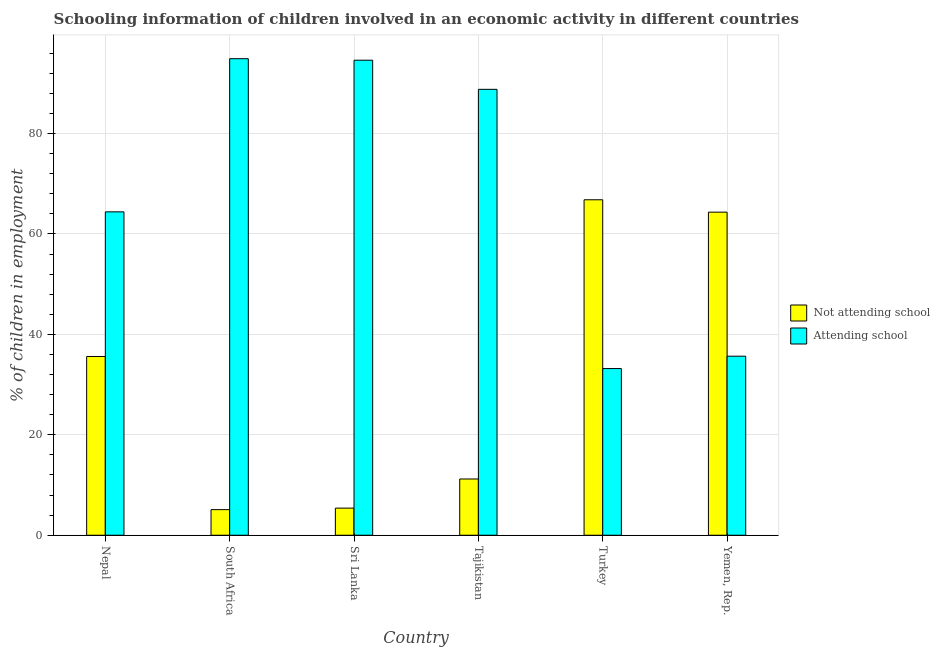How many different coloured bars are there?
Your response must be concise. 2. How many groups of bars are there?
Your answer should be very brief. 6. Are the number of bars per tick equal to the number of legend labels?
Offer a very short reply. Yes. How many bars are there on the 5th tick from the left?
Offer a terse response. 2. What is the label of the 3rd group of bars from the left?
Offer a terse response. Sri Lanka. In how many cases, is the number of bars for a given country not equal to the number of legend labels?
Make the answer very short. 0. What is the percentage of employed children who are not attending school in Sri Lanka?
Make the answer very short. 5.4. Across all countries, what is the maximum percentage of employed children who are not attending school?
Ensure brevity in your answer.  66.81. In which country was the percentage of employed children who are not attending school maximum?
Ensure brevity in your answer.  Turkey. In which country was the percentage of employed children who are not attending school minimum?
Offer a terse response. South Africa. What is the total percentage of employed children who are not attending school in the graph?
Your response must be concise. 188.45. What is the difference between the percentage of employed children who are not attending school in South Africa and that in Yemen, Rep.?
Offer a very short reply. -59.24. What is the difference between the percentage of employed children who are not attending school in Nepal and the percentage of employed children who are attending school in South Africa?
Provide a succinct answer. -59.3. What is the average percentage of employed children who are not attending school per country?
Give a very brief answer. 31.41. What is the difference between the percentage of employed children who are attending school and percentage of employed children who are not attending school in Tajikistan?
Ensure brevity in your answer.  77.6. In how many countries, is the percentage of employed children who are attending school greater than 84 %?
Your answer should be compact. 3. What is the ratio of the percentage of employed children who are not attending school in Nepal to that in Tajikistan?
Ensure brevity in your answer.  3.18. Is the percentage of employed children who are attending school in Sri Lanka less than that in Tajikistan?
Your response must be concise. No. What is the difference between the highest and the second highest percentage of employed children who are not attending school?
Offer a terse response. 2.46. What is the difference between the highest and the lowest percentage of employed children who are attending school?
Offer a very short reply. 61.71. Is the sum of the percentage of employed children who are attending school in Nepal and South Africa greater than the maximum percentage of employed children who are not attending school across all countries?
Your response must be concise. Yes. What does the 1st bar from the left in Yemen, Rep. represents?
Your answer should be compact. Not attending school. What does the 2nd bar from the right in Sri Lanka represents?
Give a very brief answer. Not attending school. How many bars are there?
Keep it short and to the point. 12. What is the difference between two consecutive major ticks on the Y-axis?
Give a very brief answer. 20. Are the values on the major ticks of Y-axis written in scientific E-notation?
Your answer should be compact. No. Does the graph contain grids?
Provide a short and direct response. Yes. How many legend labels are there?
Provide a short and direct response. 2. How are the legend labels stacked?
Offer a very short reply. Vertical. What is the title of the graph?
Provide a short and direct response. Schooling information of children involved in an economic activity in different countries. Does "Private credit bureau" appear as one of the legend labels in the graph?
Provide a short and direct response. No. What is the label or title of the Y-axis?
Offer a very short reply. % of children in employment. What is the % of children in employment in Not attending school in Nepal?
Provide a short and direct response. 35.6. What is the % of children in employment in Attending school in Nepal?
Make the answer very short. 64.4. What is the % of children in employment in Attending school in South Africa?
Provide a succinct answer. 94.9. What is the % of children in employment in Not attending school in Sri Lanka?
Offer a terse response. 5.4. What is the % of children in employment in Attending school in Sri Lanka?
Give a very brief answer. 94.6. What is the % of children in employment of Attending school in Tajikistan?
Provide a short and direct response. 88.8. What is the % of children in employment in Not attending school in Turkey?
Keep it short and to the point. 66.81. What is the % of children in employment of Attending school in Turkey?
Provide a succinct answer. 33.19. What is the % of children in employment of Not attending school in Yemen, Rep.?
Make the answer very short. 64.34. What is the % of children in employment of Attending school in Yemen, Rep.?
Your response must be concise. 35.66. Across all countries, what is the maximum % of children in employment of Not attending school?
Ensure brevity in your answer.  66.81. Across all countries, what is the maximum % of children in employment of Attending school?
Your answer should be very brief. 94.9. Across all countries, what is the minimum % of children in employment in Attending school?
Provide a short and direct response. 33.19. What is the total % of children in employment of Not attending school in the graph?
Ensure brevity in your answer.  188.45. What is the total % of children in employment in Attending school in the graph?
Your answer should be compact. 411.55. What is the difference between the % of children in employment of Not attending school in Nepal and that in South Africa?
Give a very brief answer. 30.5. What is the difference between the % of children in employment in Attending school in Nepal and that in South Africa?
Offer a terse response. -30.5. What is the difference between the % of children in employment of Not attending school in Nepal and that in Sri Lanka?
Your response must be concise. 30.2. What is the difference between the % of children in employment in Attending school in Nepal and that in Sri Lanka?
Offer a terse response. -30.2. What is the difference between the % of children in employment in Not attending school in Nepal and that in Tajikistan?
Keep it short and to the point. 24.4. What is the difference between the % of children in employment of Attending school in Nepal and that in Tajikistan?
Your response must be concise. -24.4. What is the difference between the % of children in employment in Not attending school in Nepal and that in Turkey?
Provide a succinct answer. -31.2. What is the difference between the % of children in employment in Attending school in Nepal and that in Turkey?
Your answer should be compact. 31.2. What is the difference between the % of children in employment in Not attending school in Nepal and that in Yemen, Rep.?
Offer a very short reply. -28.74. What is the difference between the % of children in employment in Attending school in Nepal and that in Yemen, Rep.?
Keep it short and to the point. 28.74. What is the difference between the % of children in employment in Attending school in South Africa and that in Sri Lanka?
Provide a succinct answer. 0.3. What is the difference between the % of children in employment in Not attending school in South Africa and that in Turkey?
Your answer should be very brief. -61.7. What is the difference between the % of children in employment of Attending school in South Africa and that in Turkey?
Provide a short and direct response. 61.7. What is the difference between the % of children in employment in Not attending school in South Africa and that in Yemen, Rep.?
Provide a succinct answer. -59.24. What is the difference between the % of children in employment of Attending school in South Africa and that in Yemen, Rep.?
Keep it short and to the point. 59.24. What is the difference between the % of children in employment of Not attending school in Sri Lanka and that in Tajikistan?
Ensure brevity in your answer.  -5.8. What is the difference between the % of children in employment of Attending school in Sri Lanka and that in Tajikistan?
Offer a terse response. 5.8. What is the difference between the % of children in employment in Not attending school in Sri Lanka and that in Turkey?
Offer a very short reply. -61.41. What is the difference between the % of children in employment of Attending school in Sri Lanka and that in Turkey?
Ensure brevity in your answer.  61.41. What is the difference between the % of children in employment of Not attending school in Sri Lanka and that in Yemen, Rep.?
Keep it short and to the point. -58.94. What is the difference between the % of children in employment of Attending school in Sri Lanka and that in Yemen, Rep.?
Give a very brief answer. 58.94. What is the difference between the % of children in employment in Not attending school in Tajikistan and that in Turkey?
Keep it short and to the point. -55.6. What is the difference between the % of children in employment of Attending school in Tajikistan and that in Turkey?
Your response must be concise. 55.6. What is the difference between the % of children in employment of Not attending school in Tajikistan and that in Yemen, Rep.?
Keep it short and to the point. -53.14. What is the difference between the % of children in employment in Attending school in Tajikistan and that in Yemen, Rep.?
Provide a succinct answer. 53.14. What is the difference between the % of children in employment in Not attending school in Turkey and that in Yemen, Rep.?
Make the answer very short. 2.46. What is the difference between the % of children in employment of Attending school in Turkey and that in Yemen, Rep.?
Keep it short and to the point. -2.46. What is the difference between the % of children in employment in Not attending school in Nepal and the % of children in employment in Attending school in South Africa?
Your answer should be compact. -59.3. What is the difference between the % of children in employment in Not attending school in Nepal and the % of children in employment in Attending school in Sri Lanka?
Your answer should be compact. -59. What is the difference between the % of children in employment in Not attending school in Nepal and the % of children in employment in Attending school in Tajikistan?
Your response must be concise. -53.2. What is the difference between the % of children in employment of Not attending school in Nepal and the % of children in employment of Attending school in Turkey?
Offer a terse response. 2.4. What is the difference between the % of children in employment of Not attending school in Nepal and the % of children in employment of Attending school in Yemen, Rep.?
Keep it short and to the point. -0.06. What is the difference between the % of children in employment of Not attending school in South Africa and the % of children in employment of Attending school in Sri Lanka?
Keep it short and to the point. -89.5. What is the difference between the % of children in employment of Not attending school in South Africa and the % of children in employment of Attending school in Tajikistan?
Ensure brevity in your answer.  -83.7. What is the difference between the % of children in employment of Not attending school in South Africa and the % of children in employment of Attending school in Turkey?
Provide a short and direct response. -28.09. What is the difference between the % of children in employment in Not attending school in South Africa and the % of children in employment in Attending school in Yemen, Rep.?
Provide a succinct answer. -30.56. What is the difference between the % of children in employment in Not attending school in Sri Lanka and the % of children in employment in Attending school in Tajikistan?
Offer a terse response. -83.4. What is the difference between the % of children in employment in Not attending school in Sri Lanka and the % of children in employment in Attending school in Turkey?
Offer a terse response. -27.8. What is the difference between the % of children in employment of Not attending school in Sri Lanka and the % of children in employment of Attending school in Yemen, Rep.?
Keep it short and to the point. -30.26. What is the difference between the % of children in employment in Not attending school in Tajikistan and the % of children in employment in Attending school in Turkey?
Provide a succinct answer. -22. What is the difference between the % of children in employment in Not attending school in Tajikistan and the % of children in employment in Attending school in Yemen, Rep.?
Keep it short and to the point. -24.46. What is the difference between the % of children in employment in Not attending school in Turkey and the % of children in employment in Attending school in Yemen, Rep.?
Offer a terse response. 31.15. What is the average % of children in employment in Not attending school per country?
Offer a very short reply. 31.41. What is the average % of children in employment of Attending school per country?
Provide a short and direct response. 68.59. What is the difference between the % of children in employment in Not attending school and % of children in employment in Attending school in Nepal?
Your response must be concise. -28.8. What is the difference between the % of children in employment of Not attending school and % of children in employment of Attending school in South Africa?
Give a very brief answer. -89.8. What is the difference between the % of children in employment of Not attending school and % of children in employment of Attending school in Sri Lanka?
Make the answer very short. -89.2. What is the difference between the % of children in employment of Not attending school and % of children in employment of Attending school in Tajikistan?
Your answer should be very brief. -77.6. What is the difference between the % of children in employment in Not attending school and % of children in employment in Attending school in Turkey?
Keep it short and to the point. 33.61. What is the difference between the % of children in employment in Not attending school and % of children in employment in Attending school in Yemen, Rep.?
Your answer should be compact. 28.68. What is the ratio of the % of children in employment in Not attending school in Nepal to that in South Africa?
Your response must be concise. 6.98. What is the ratio of the % of children in employment of Attending school in Nepal to that in South Africa?
Keep it short and to the point. 0.68. What is the ratio of the % of children in employment in Not attending school in Nepal to that in Sri Lanka?
Ensure brevity in your answer.  6.59. What is the ratio of the % of children in employment of Attending school in Nepal to that in Sri Lanka?
Your answer should be compact. 0.68. What is the ratio of the % of children in employment of Not attending school in Nepal to that in Tajikistan?
Provide a short and direct response. 3.18. What is the ratio of the % of children in employment of Attending school in Nepal to that in Tajikistan?
Ensure brevity in your answer.  0.73. What is the ratio of the % of children in employment in Not attending school in Nepal to that in Turkey?
Your response must be concise. 0.53. What is the ratio of the % of children in employment of Attending school in Nepal to that in Turkey?
Give a very brief answer. 1.94. What is the ratio of the % of children in employment in Not attending school in Nepal to that in Yemen, Rep.?
Make the answer very short. 0.55. What is the ratio of the % of children in employment in Attending school in Nepal to that in Yemen, Rep.?
Offer a very short reply. 1.81. What is the ratio of the % of children in employment in Not attending school in South Africa to that in Sri Lanka?
Your answer should be very brief. 0.94. What is the ratio of the % of children in employment of Attending school in South Africa to that in Sri Lanka?
Keep it short and to the point. 1. What is the ratio of the % of children in employment in Not attending school in South Africa to that in Tajikistan?
Provide a short and direct response. 0.46. What is the ratio of the % of children in employment in Attending school in South Africa to that in Tajikistan?
Offer a very short reply. 1.07. What is the ratio of the % of children in employment of Not attending school in South Africa to that in Turkey?
Your answer should be compact. 0.08. What is the ratio of the % of children in employment of Attending school in South Africa to that in Turkey?
Ensure brevity in your answer.  2.86. What is the ratio of the % of children in employment of Not attending school in South Africa to that in Yemen, Rep.?
Your response must be concise. 0.08. What is the ratio of the % of children in employment in Attending school in South Africa to that in Yemen, Rep.?
Keep it short and to the point. 2.66. What is the ratio of the % of children in employment in Not attending school in Sri Lanka to that in Tajikistan?
Provide a short and direct response. 0.48. What is the ratio of the % of children in employment in Attending school in Sri Lanka to that in Tajikistan?
Keep it short and to the point. 1.07. What is the ratio of the % of children in employment of Not attending school in Sri Lanka to that in Turkey?
Keep it short and to the point. 0.08. What is the ratio of the % of children in employment of Attending school in Sri Lanka to that in Turkey?
Make the answer very short. 2.85. What is the ratio of the % of children in employment of Not attending school in Sri Lanka to that in Yemen, Rep.?
Offer a very short reply. 0.08. What is the ratio of the % of children in employment of Attending school in Sri Lanka to that in Yemen, Rep.?
Offer a terse response. 2.65. What is the ratio of the % of children in employment in Not attending school in Tajikistan to that in Turkey?
Make the answer very short. 0.17. What is the ratio of the % of children in employment in Attending school in Tajikistan to that in Turkey?
Make the answer very short. 2.68. What is the ratio of the % of children in employment of Not attending school in Tajikistan to that in Yemen, Rep.?
Your answer should be compact. 0.17. What is the ratio of the % of children in employment of Attending school in Tajikistan to that in Yemen, Rep.?
Offer a very short reply. 2.49. What is the ratio of the % of children in employment in Not attending school in Turkey to that in Yemen, Rep.?
Provide a short and direct response. 1.04. What is the ratio of the % of children in employment of Attending school in Turkey to that in Yemen, Rep.?
Ensure brevity in your answer.  0.93. What is the difference between the highest and the second highest % of children in employment in Not attending school?
Offer a very short reply. 2.46. What is the difference between the highest and the second highest % of children in employment of Attending school?
Provide a short and direct response. 0.3. What is the difference between the highest and the lowest % of children in employment of Not attending school?
Offer a terse response. 61.7. What is the difference between the highest and the lowest % of children in employment of Attending school?
Offer a terse response. 61.7. 